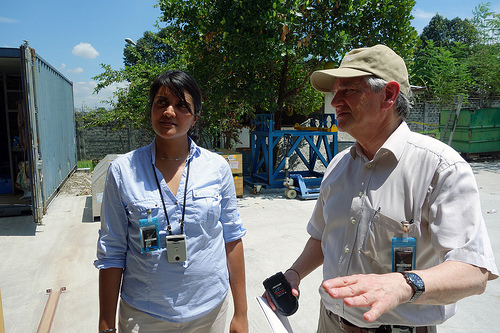<image>
Is there a cell phone in the woman? No. The cell phone is not contained within the woman. These objects have a different spatial relationship. 